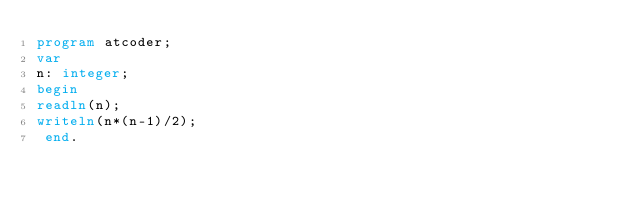Convert code to text. <code><loc_0><loc_0><loc_500><loc_500><_Pascal_>program atcoder;
var
n: integer;
begin
readln(n);
writeln(n*(n-1)/2);
 end.</code> 